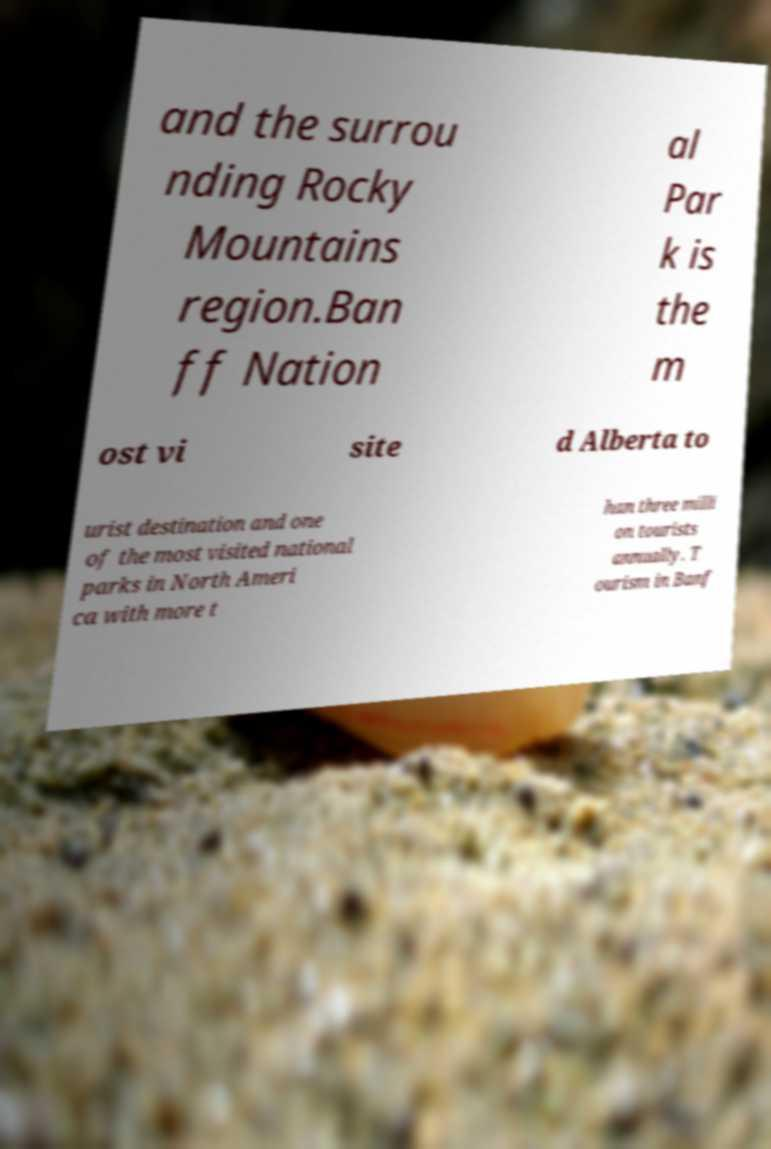For documentation purposes, I need the text within this image transcribed. Could you provide that? and the surrou nding Rocky Mountains region.Ban ff Nation al Par k is the m ost vi site d Alberta to urist destination and one of the most visited national parks in North Ameri ca with more t han three milli on tourists annually. T ourism in Banf 